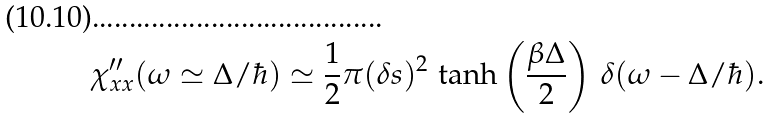<formula> <loc_0><loc_0><loc_500><loc_500>\chi ^ { \prime \prime } _ { x x } ( \omega \simeq \Delta / \hbar { ) } \simeq \frac { 1 } { 2 } \pi ( \delta s ) ^ { 2 } \, \tanh \left ( \frac { \beta \Delta } { 2 } \right ) \, \delta ( \omega - \Delta / \hbar { ) } .</formula> 